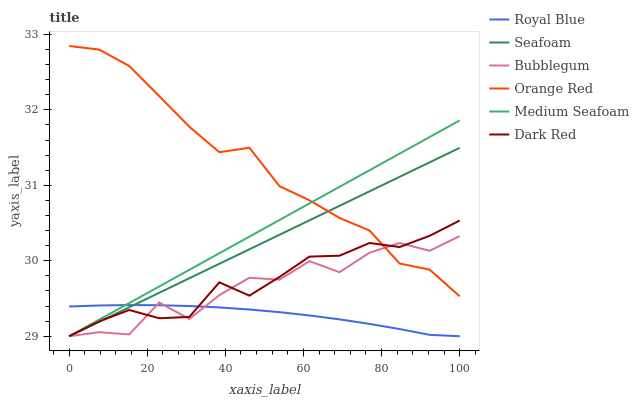Does Royal Blue have the minimum area under the curve?
Answer yes or no. Yes. Does Orange Red have the maximum area under the curve?
Answer yes or no. Yes. Does Seafoam have the minimum area under the curve?
Answer yes or no. No. Does Seafoam have the maximum area under the curve?
Answer yes or no. No. Is Seafoam the smoothest?
Answer yes or no. Yes. Is Bubblegum the roughest?
Answer yes or no. Yes. Is Bubblegum the smoothest?
Answer yes or no. No. Is Seafoam the roughest?
Answer yes or no. No. Does Dark Red have the lowest value?
Answer yes or no. Yes. Does Orange Red have the lowest value?
Answer yes or no. No. Does Orange Red have the highest value?
Answer yes or no. Yes. Does Seafoam have the highest value?
Answer yes or no. No. Is Royal Blue less than Orange Red?
Answer yes or no. Yes. Is Orange Red greater than Royal Blue?
Answer yes or no. Yes. Does Seafoam intersect Dark Red?
Answer yes or no. Yes. Is Seafoam less than Dark Red?
Answer yes or no. No. Is Seafoam greater than Dark Red?
Answer yes or no. No. Does Royal Blue intersect Orange Red?
Answer yes or no. No. 